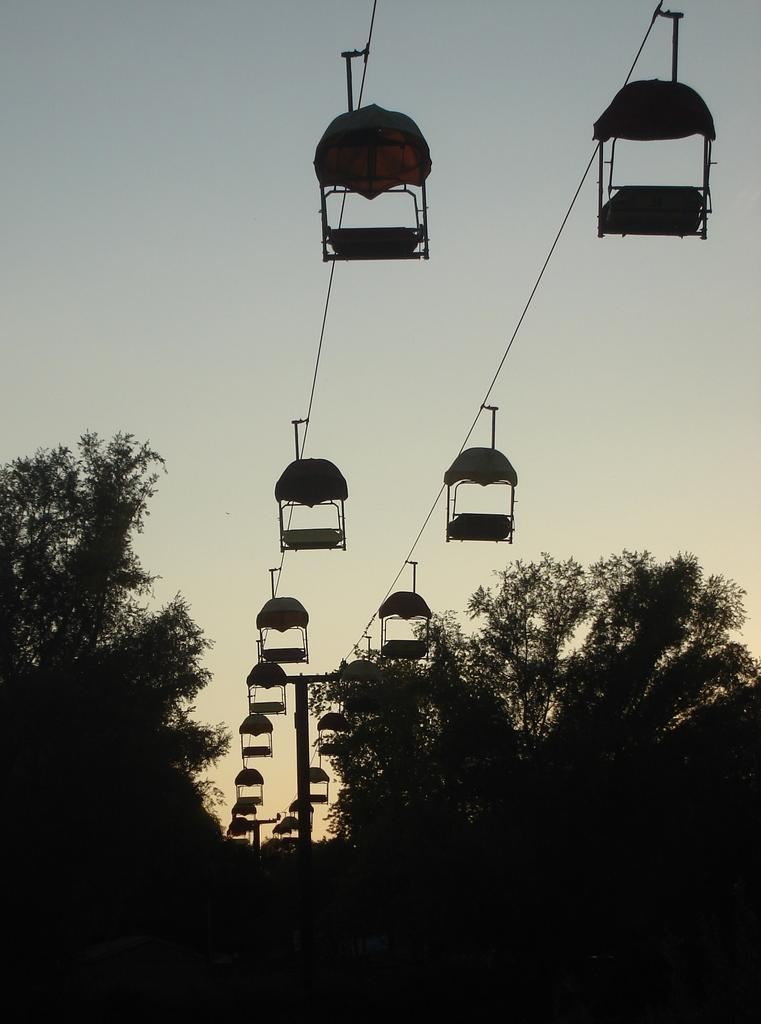What type of vegetation is at the bottom of the image? There are trees at the bottom of the image. What mode of transportation can be seen in the center of the image? There are cable cars in the center of the image. What is present in the image that connects the cable cars? There are wires in the image. What is visible at the top of the image? The sky is visible at the top of the image. What type of pencil can be seen in the image? There is no pencil present in the image. Is there a bike visible in the image? No, there is no bike visible in the image. 